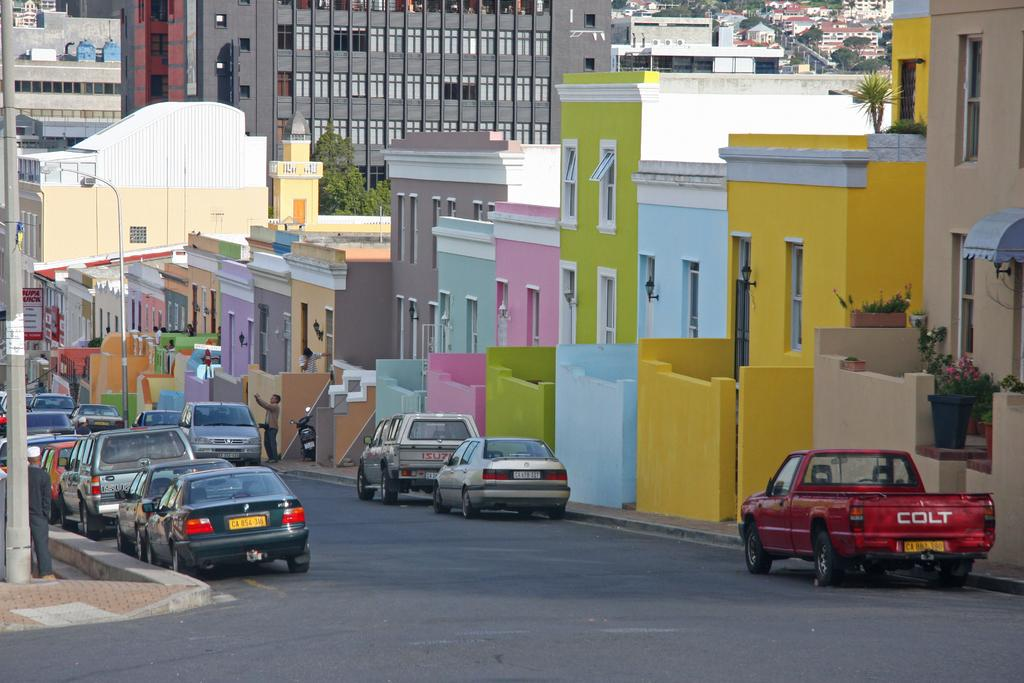<image>
Render a clear and concise summary of the photo. A street with pastel painted buildings and cars parked along it. 